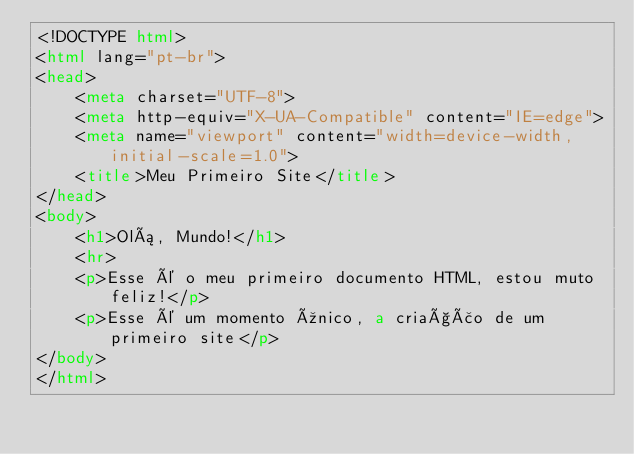<code> <loc_0><loc_0><loc_500><loc_500><_HTML_><!DOCTYPE html>
<html lang="pt-br">
<head>
    <meta charset="UTF-8">
    <meta http-equiv="X-UA-Compatible" content="IE=edge">
    <meta name="viewport" content="width=device-width, initial-scale=1.0">
    <title>Meu Primeiro Site</title>
</head>
<body>
    <h1>Olá, Mundo!</h1>
    <hr>
    <p>Esse é o meu primeiro documento HTML, estou muto feliz!</p>
    <p>Esse é um momento único, a criação de um primeiro site</p>
</body>
</html></code> 